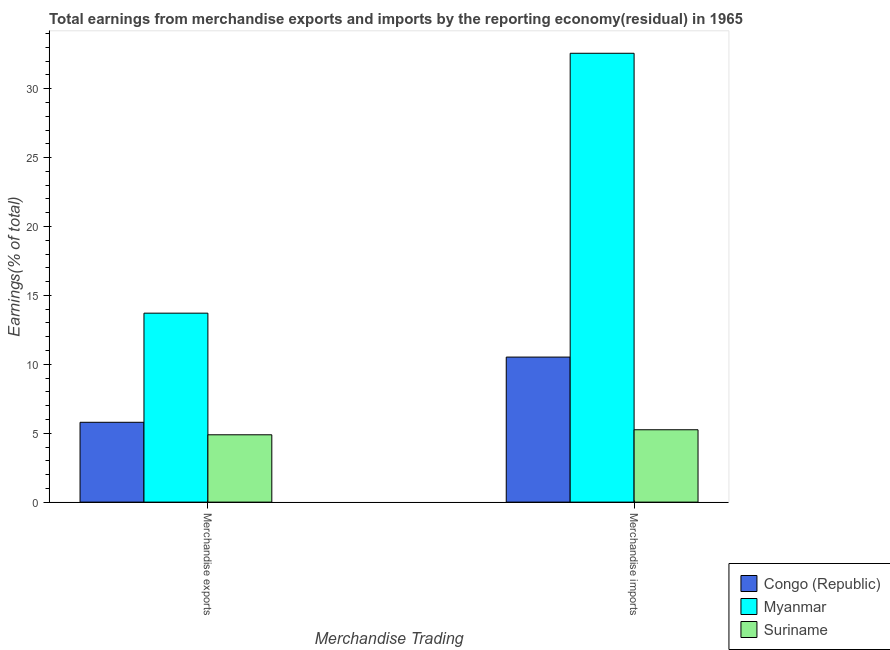How many different coloured bars are there?
Keep it short and to the point. 3. Are the number of bars on each tick of the X-axis equal?
Provide a short and direct response. Yes. How many bars are there on the 1st tick from the left?
Provide a short and direct response. 3. How many bars are there on the 1st tick from the right?
Your answer should be compact. 3. What is the label of the 1st group of bars from the left?
Keep it short and to the point. Merchandise exports. What is the earnings from merchandise imports in Congo (Republic)?
Give a very brief answer. 10.53. Across all countries, what is the maximum earnings from merchandise exports?
Provide a short and direct response. 13.71. Across all countries, what is the minimum earnings from merchandise imports?
Make the answer very short. 5.25. In which country was the earnings from merchandise exports maximum?
Provide a succinct answer. Myanmar. In which country was the earnings from merchandise imports minimum?
Your response must be concise. Suriname. What is the total earnings from merchandise exports in the graph?
Give a very brief answer. 24.39. What is the difference between the earnings from merchandise imports in Myanmar and that in Congo (Republic)?
Provide a short and direct response. 22.05. What is the difference between the earnings from merchandise imports in Myanmar and the earnings from merchandise exports in Congo (Republic)?
Ensure brevity in your answer.  26.78. What is the average earnings from merchandise exports per country?
Give a very brief answer. 8.13. What is the difference between the earnings from merchandise exports and earnings from merchandise imports in Congo (Republic)?
Your response must be concise. -4.73. What is the ratio of the earnings from merchandise exports in Myanmar to that in Congo (Republic)?
Ensure brevity in your answer.  2.37. Is the earnings from merchandise imports in Myanmar less than that in Congo (Republic)?
Keep it short and to the point. No. What does the 1st bar from the left in Merchandise imports represents?
Your response must be concise. Congo (Republic). What does the 3rd bar from the right in Merchandise imports represents?
Make the answer very short. Congo (Republic). How many countries are there in the graph?
Give a very brief answer. 3. Are the values on the major ticks of Y-axis written in scientific E-notation?
Offer a terse response. No. Where does the legend appear in the graph?
Ensure brevity in your answer.  Bottom right. How many legend labels are there?
Your answer should be compact. 3. How are the legend labels stacked?
Your answer should be very brief. Vertical. What is the title of the graph?
Ensure brevity in your answer.  Total earnings from merchandise exports and imports by the reporting economy(residual) in 1965. What is the label or title of the X-axis?
Your answer should be very brief. Merchandise Trading. What is the label or title of the Y-axis?
Provide a succinct answer. Earnings(% of total). What is the Earnings(% of total) of Congo (Republic) in Merchandise exports?
Ensure brevity in your answer.  5.79. What is the Earnings(% of total) in Myanmar in Merchandise exports?
Your answer should be very brief. 13.71. What is the Earnings(% of total) of Suriname in Merchandise exports?
Your answer should be compact. 4.89. What is the Earnings(% of total) of Congo (Republic) in Merchandise imports?
Your answer should be compact. 10.53. What is the Earnings(% of total) in Myanmar in Merchandise imports?
Provide a succinct answer. 32.58. What is the Earnings(% of total) in Suriname in Merchandise imports?
Your answer should be compact. 5.25. Across all Merchandise Trading, what is the maximum Earnings(% of total) of Congo (Republic)?
Offer a very short reply. 10.53. Across all Merchandise Trading, what is the maximum Earnings(% of total) in Myanmar?
Provide a succinct answer. 32.58. Across all Merchandise Trading, what is the maximum Earnings(% of total) in Suriname?
Your response must be concise. 5.25. Across all Merchandise Trading, what is the minimum Earnings(% of total) in Congo (Republic)?
Provide a succinct answer. 5.79. Across all Merchandise Trading, what is the minimum Earnings(% of total) in Myanmar?
Offer a very short reply. 13.71. Across all Merchandise Trading, what is the minimum Earnings(% of total) in Suriname?
Provide a succinct answer. 4.89. What is the total Earnings(% of total) in Congo (Republic) in the graph?
Make the answer very short. 16.32. What is the total Earnings(% of total) in Myanmar in the graph?
Ensure brevity in your answer.  46.29. What is the total Earnings(% of total) of Suriname in the graph?
Your response must be concise. 10.14. What is the difference between the Earnings(% of total) in Congo (Republic) in Merchandise exports and that in Merchandise imports?
Offer a terse response. -4.73. What is the difference between the Earnings(% of total) in Myanmar in Merchandise exports and that in Merchandise imports?
Ensure brevity in your answer.  -18.86. What is the difference between the Earnings(% of total) in Suriname in Merchandise exports and that in Merchandise imports?
Your answer should be compact. -0.37. What is the difference between the Earnings(% of total) of Congo (Republic) in Merchandise exports and the Earnings(% of total) of Myanmar in Merchandise imports?
Provide a succinct answer. -26.78. What is the difference between the Earnings(% of total) in Congo (Republic) in Merchandise exports and the Earnings(% of total) in Suriname in Merchandise imports?
Provide a succinct answer. 0.54. What is the difference between the Earnings(% of total) of Myanmar in Merchandise exports and the Earnings(% of total) of Suriname in Merchandise imports?
Provide a short and direct response. 8.46. What is the average Earnings(% of total) of Congo (Republic) per Merchandise Trading?
Provide a short and direct response. 8.16. What is the average Earnings(% of total) of Myanmar per Merchandise Trading?
Ensure brevity in your answer.  23.14. What is the average Earnings(% of total) of Suriname per Merchandise Trading?
Ensure brevity in your answer.  5.07. What is the difference between the Earnings(% of total) of Congo (Republic) and Earnings(% of total) of Myanmar in Merchandise exports?
Ensure brevity in your answer.  -7.92. What is the difference between the Earnings(% of total) in Congo (Republic) and Earnings(% of total) in Suriname in Merchandise exports?
Give a very brief answer. 0.91. What is the difference between the Earnings(% of total) in Myanmar and Earnings(% of total) in Suriname in Merchandise exports?
Make the answer very short. 8.83. What is the difference between the Earnings(% of total) of Congo (Republic) and Earnings(% of total) of Myanmar in Merchandise imports?
Your answer should be compact. -22.05. What is the difference between the Earnings(% of total) of Congo (Republic) and Earnings(% of total) of Suriname in Merchandise imports?
Give a very brief answer. 5.27. What is the difference between the Earnings(% of total) of Myanmar and Earnings(% of total) of Suriname in Merchandise imports?
Your answer should be compact. 27.32. What is the ratio of the Earnings(% of total) in Congo (Republic) in Merchandise exports to that in Merchandise imports?
Ensure brevity in your answer.  0.55. What is the ratio of the Earnings(% of total) in Myanmar in Merchandise exports to that in Merchandise imports?
Offer a terse response. 0.42. What is the ratio of the Earnings(% of total) in Suriname in Merchandise exports to that in Merchandise imports?
Provide a short and direct response. 0.93. What is the difference between the highest and the second highest Earnings(% of total) of Congo (Republic)?
Ensure brevity in your answer.  4.73. What is the difference between the highest and the second highest Earnings(% of total) of Myanmar?
Offer a terse response. 18.86. What is the difference between the highest and the second highest Earnings(% of total) of Suriname?
Your response must be concise. 0.37. What is the difference between the highest and the lowest Earnings(% of total) of Congo (Republic)?
Keep it short and to the point. 4.73. What is the difference between the highest and the lowest Earnings(% of total) of Myanmar?
Give a very brief answer. 18.86. What is the difference between the highest and the lowest Earnings(% of total) in Suriname?
Your answer should be compact. 0.37. 